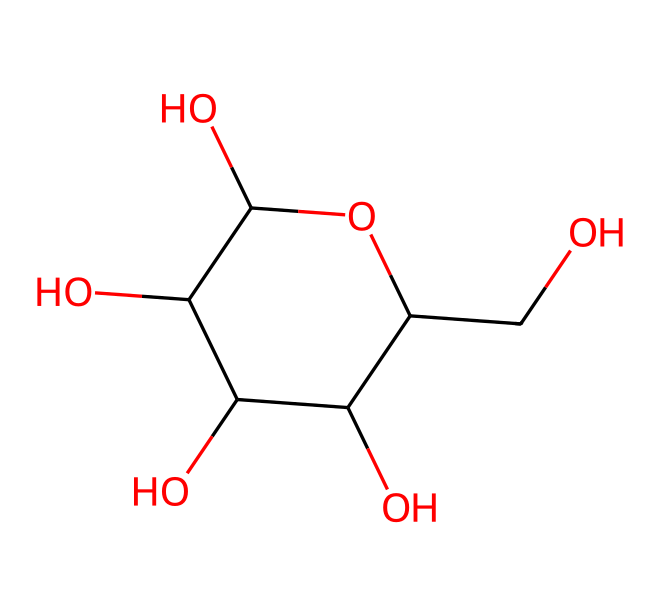What is the molecular formula of glucose? The SMILES representation can be broken down to count the atoms present. In this case, we see 6 carbons (C), 12 hydrogens (H), and 6 oxygens (O). Therefore, the molecular formula is C6H12O6.
Answer: C6H12O6 How many carbon atoms are in glucose? By analyzing the SMILES representation, we can see that there are 6 carbon atoms (C) in the structure of glucose. Counting the 'C' symbols consistently confirms this.
Answer: 6 What type of carbohydrate is glucose? Glucose is a monosaccharide, which is a simple sugar and the most basic unit of carbohydrates. The structure illustrates a single sugar unit.
Answer: monosaccharide How many hydroxyl (–OH) groups are present in glucose? The structure shows that glucose contains five hydroxyl (–OH) groups, which can be identified by the 'O' connected to 'H' within the molecule.
Answer: 5 Which part of glucose contributes to its sweetness? The presence of multiple hydroxyl (–OH) groups plays a crucial role in making glucose sweet, as these functional groups interact with taste receptors.
Answer: hydroxyl groups What is the role of glucose in nutrition? Glucose serves as a primary energy source for many organisms, including humans. The structure's arrangement allows it to be easily metabolized for energy.
Answer: energy source 